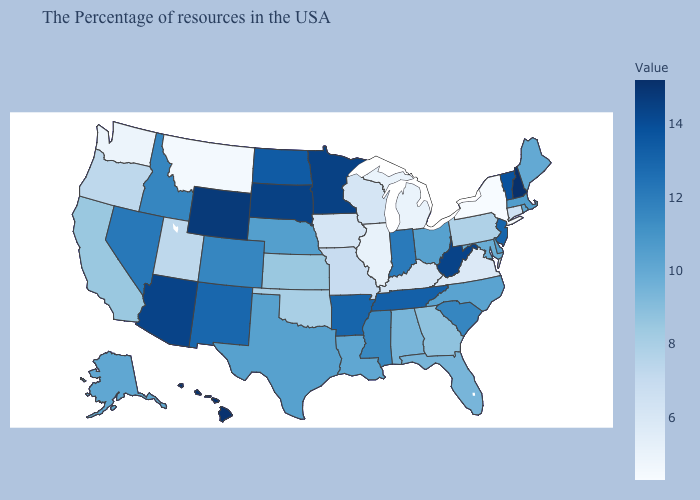Which states hav the highest value in the South?
Quick response, please. West Virginia. Does South Carolina have a lower value than Tennessee?
Short answer required. Yes. Is the legend a continuous bar?
Give a very brief answer. Yes. Does Tennessee have the highest value in the USA?
Answer briefly. No. Which states have the lowest value in the USA?
Be succinct. New York. Among the states that border Texas , which have the lowest value?
Write a very short answer. Oklahoma. Does Virginia have the lowest value in the South?
Quick response, please. Yes. 